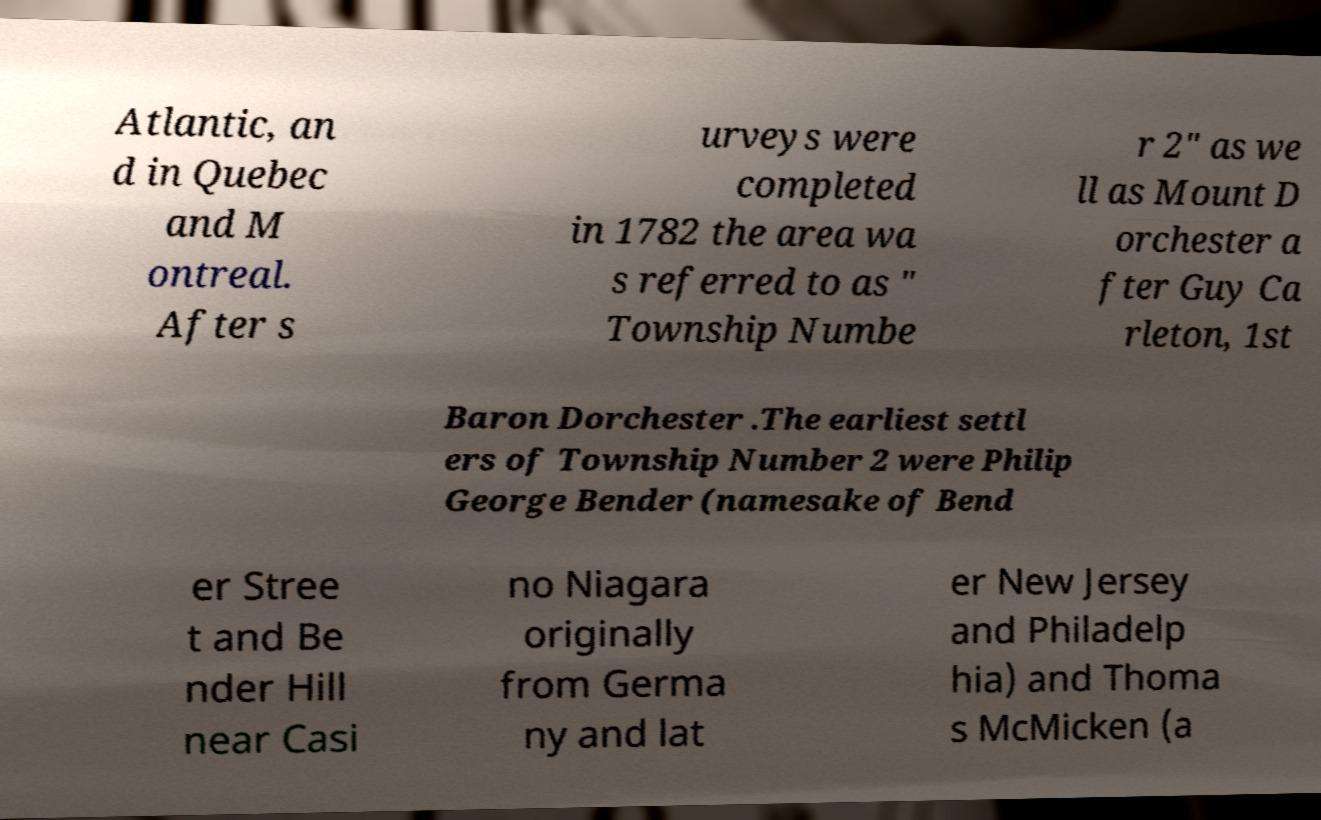There's text embedded in this image that I need extracted. Can you transcribe it verbatim? Atlantic, an d in Quebec and M ontreal. After s urveys were completed in 1782 the area wa s referred to as " Township Numbe r 2" as we ll as Mount D orchester a fter Guy Ca rleton, 1st Baron Dorchester .The earliest settl ers of Township Number 2 were Philip George Bender (namesake of Bend er Stree t and Be nder Hill near Casi no Niagara originally from Germa ny and lat er New Jersey and Philadelp hia) and Thoma s McMicken (a 